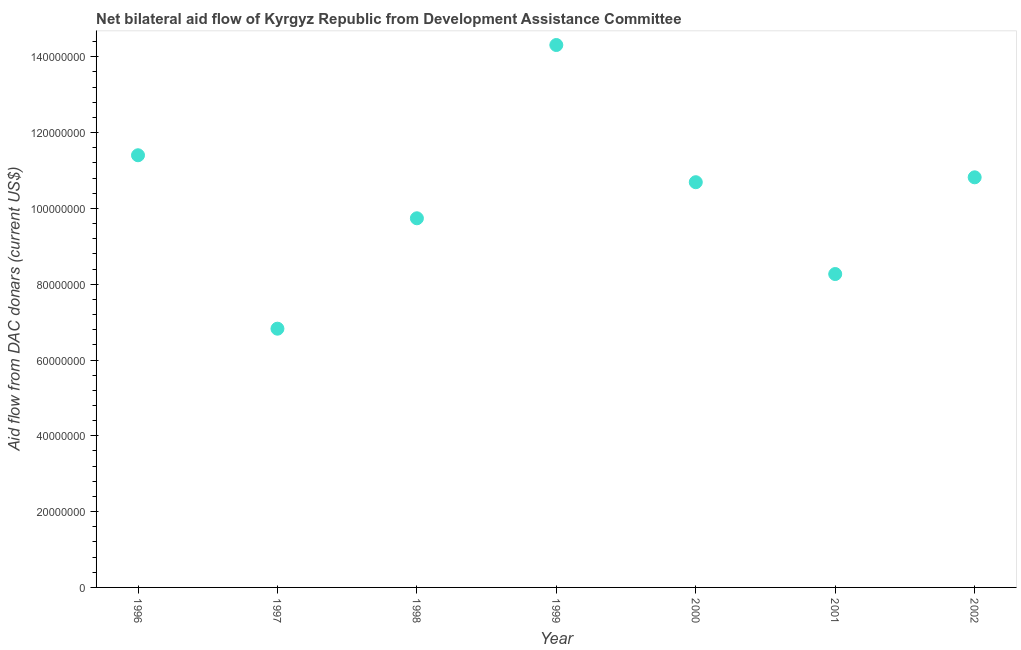What is the net bilateral aid flows from dac donors in 1996?
Make the answer very short. 1.14e+08. Across all years, what is the maximum net bilateral aid flows from dac donors?
Your answer should be compact. 1.43e+08. Across all years, what is the minimum net bilateral aid flows from dac donors?
Ensure brevity in your answer.  6.83e+07. What is the sum of the net bilateral aid flows from dac donors?
Provide a succinct answer. 7.21e+08. What is the difference between the net bilateral aid flows from dac donors in 1997 and 1998?
Ensure brevity in your answer.  -2.91e+07. What is the average net bilateral aid flows from dac donors per year?
Your answer should be compact. 1.03e+08. What is the median net bilateral aid flows from dac donors?
Provide a short and direct response. 1.07e+08. Do a majority of the years between 2001 and 1996 (inclusive) have net bilateral aid flows from dac donors greater than 120000000 US$?
Offer a terse response. Yes. What is the ratio of the net bilateral aid flows from dac donors in 1997 to that in 2001?
Provide a short and direct response. 0.83. Is the difference between the net bilateral aid flows from dac donors in 2001 and 2002 greater than the difference between any two years?
Give a very brief answer. No. What is the difference between the highest and the second highest net bilateral aid flows from dac donors?
Your answer should be compact. 2.91e+07. Is the sum of the net bilateral aid flows from dac donors in 1999 and 2001 greater than the maximum net bilateral aid flows from dac donors across all years?
Provide a succinct answer. Yes. What is the difference between the highest and the lowest net bilateral aid flows from dac donors?
Make the answer very short. 7.48e+07. Does the net bilateral aid flows from dac donors monotonically increase over the years?
Provide a short and direct response. No. How many dotlines are there?
Your answer should be very brief. 1. How many years are there in the graph?
Keep it short and to the point. 7. What is the difference between two consecutive major ticks on the Y-axis?
Provide a short and direct response. 2.00e+07. Are the values on the major ticks of Y-axis written in scientific E-notation?
Ensure brevity in your answer.  No. Does the graph contain any zero values?
Give a very brief answer. No. What is the title of the graph?
Your answer should be compact. Net bilateral aid flow of Kyrgyz Republic from Development Assistance Committee. What is the label or title of the Y-axis?
Provide a short and direct response. Aid flow from DAC donars (current US$). What is the Aid flow from DAC donars (current US$) in 1996?
Provide a succinct answer. 1.14e+08. What is the Aid flow from DAC donars (current US$) in 1997?
Your answer should be very brief. 6.83e+07. What is the Aid flow from DAC donars (current US$) in 1998?
Give a very brief answer. 9.74e+07. What is the Aid flow from DAC donars (current US$) in 1999?
Make the answer very short. 1.43e+08. What is the Aid flow from DAC donars (current US$) in 2000?
Offer a terse response. 1.07e+08. What is the Aid flow from DAC donars (current US$) in 2001?
Offer a terse response. 8.27e+07. What is the Aid flow from DAC donars (current US$) in 2002?
Keep it short and to the point. 1.08e+08. What is the difference between the Aid flow from DAC donars (current US$) in 1996 and 1997?
Provide a short and direct response. 4.58e+07. What is the difference between the Aid flow from DAC donars (current US$) in 1996 and 1998?
Give a very brief answer. 1.66e+07. What is the difference between the Aid flow from DAC donars (current US$) in 1996 and 1999?
Your response must be concise. -2.91e+07. What is the difference between the Aid flow from DAC donars (current US$) in 1996 and 2000?
Ensure brevity in your answer.  7.11e+06. What is the difference between the Aid flow from DAC donars (current US$) in 1996 and 2001?
Your answer should be very brief. 3.13e+07. What is the difference between the Aid flow from DAC donars (current US$) in 1996 and 2002?
Ensure brevity in your answer.  5.82e+06. What is the difference between the Aid flow from DAC donars (current US$) in 1997 and 1998?
Ensure brevity in your answer.  -2.91e+07. What is the difference between the Aid flow from DAC donars (current US$) in 1997 and 1999?
Your response must be concise. -7.48e+07. What is the difference between the Aid flow from DAC donars (current US$) in 1997 and 2000?
Provide a short and direct response. -3.86e+07. What is the difference between the Aid flow from DAC donars (current US$) in 1997 and 2001?
Offer a very short reply. -1.44e+07. What is the difference between the Aid flow from DAC donars (current US$) in 1997 and 2002?
Offer a terse response. -3.99e+07. What is the difference between the Aid flow from DAC donars (current US$) in 1998 and 1999?
Ensure brevity in your answer.  -4.57e+07. What is the difference between the Aid flow from DAC donars (current US$) in 1998 and 2000?
Keep it short and to the point. -9.52e+06. What is the difference between the Aid flow from DAC donars (current US$) in 1998 and 2001?
Provide a short and direct response. 1.47e+07. What is the difference between the Aid flow from DAC donars (current US$) in 1998 and 2002?
Your response must be concise. -1.08e+07. What is the difference between the Aid flow from DAC donars (current US$) in 1999 and 2000?
Your response must be concise. 3.62e+07. What is the difference between the Aid flow from DAC donars (current US$) in 1999 and 2001?
Give a very brief answer. 6.04e+07. What is the difference between the Aid flow from DAC donars (current US$) in 1999 and 2002?
Keep it short and to the point. 3.49e+07. What is the difference between the Aid flow from DAC donars (current US$) in 2000 and 2001?
Give a very brief answer. 2.42e+07. What is the difference between the Aid flow from DAC donars (current US$) in 2000 and 2002?
Make the answer very short. -1.29e+06. What is the difference between the Aid flow from DAC donars (current US$) in 2001 and 2002?
Provide a short and direct response. -2.55e+07. What is the ratio of the Aid flow from DAC donars (current US$) in 1996 to that in 1997?
Give a very brief answer. 1.67. What is the ratio of the Aid flow from DAC donars (current US$) in 1996 to that in 1998?
Your answer should be compact. 1.17. What is the ratio of the Aid flow from DAC donars (current US$) in 1996 to that in 1999?
Ensure brevity in your answer.  0.8. What is the ratio of the Aid flow from DAC donars (current US$) in 1996 to that in 2000?
Ensure brevity in your answer.  1.07. What is the ratio of the Aid flow from DAC donars (current US$) in 1996 to that in 2001?
Provide a short and direct response. 1.38. What is the ratio of the Aid flow from DAC donars (current US$) in 1996 to that in 2002?
Ensure brevity in your answer.  1.05. What is the ratio of the Aid flow from DAC donars (current US$) in 1997 to that in 1998?
Your answer should be very brief. 0.7. What is the ratio of the Aid flow from DAC donars (current US$) in 1997 to that in 1999?
Offer a terse response. 0.48. What is the ratio of the Aid flow from DAC donars (current US$) in 1997 to that in 2000?
Your response must be concise. 0.64. What is the ratio of the Aid flow from DAC donars (current US$) in 1997 to that in 2001?
Ensure brevity in your answer.  0.83. What is the ratio of the Aid flow from DAC donars (current US$) in 1997 to that in 2002?
Your answer should be compact. 0.63. What is the ratio of the Aid flow from DAC donars (current US$) in 1998 to that in 1999?
Your answer should be very brief. 0.68. What is the ratio of the Aid flow from DAC donars (current US$) in 1998 to that in 2000?
Keep it short and to the point. 0.91. What is the ratio of the Aid flow from DAC donars (current US$) in 1998 to that in 2001?
Your response must be concise. 1.18. What is the ratio of the Aid flow from DAC donars (current US$) in 1999 to that in 2000?
Give a very brief answer. 1.34. What is the ratio of the Aid flow from DAC donars (current US$) in 1999 to that in 2001?
Your answer should be very brief. 1.73. What is the ratio of the Aid flow from DAC donars (current US$) in 1999 to that in 2002?
Ensure brevity in your answer.  1.32. What is the ratio of the Aid flow from DAC donars (current US$) in 2000 to that in 2001?
Your response must be concise. 1.29. What is the ratio of the Aid flow from DAC donars (current US$) in 2001 to that in 2002?
Provide a succinct answer. 0.76. 